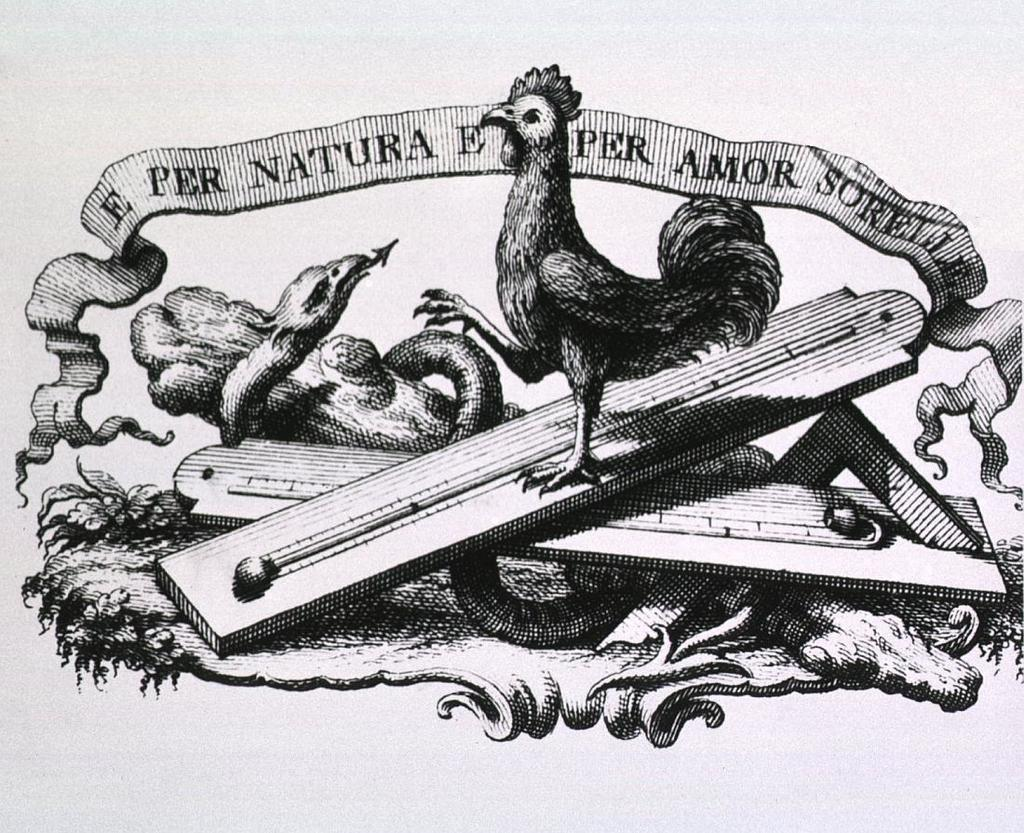What animals are depicted in the image? There is a depiction of a cock and a snake in the image. What other elements can be seen in the image? There is text written in the image. What is the color scheme of the image? The image is black and white in color. How does the beggar interact with the cock and snake in the image? There is no beggar present in the image; it only features a cock, a snake, and text. 